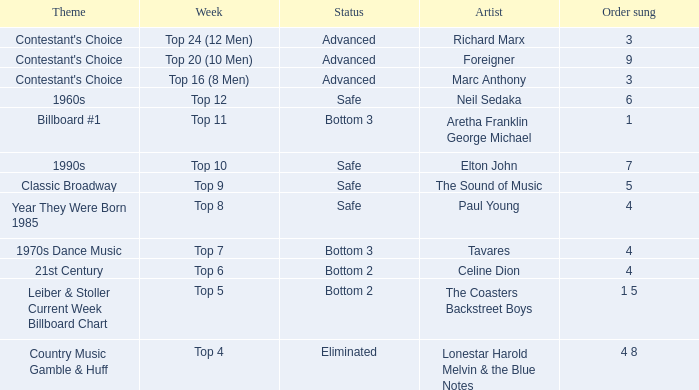What order was the performance of a Richard Marx song? 3.0. 